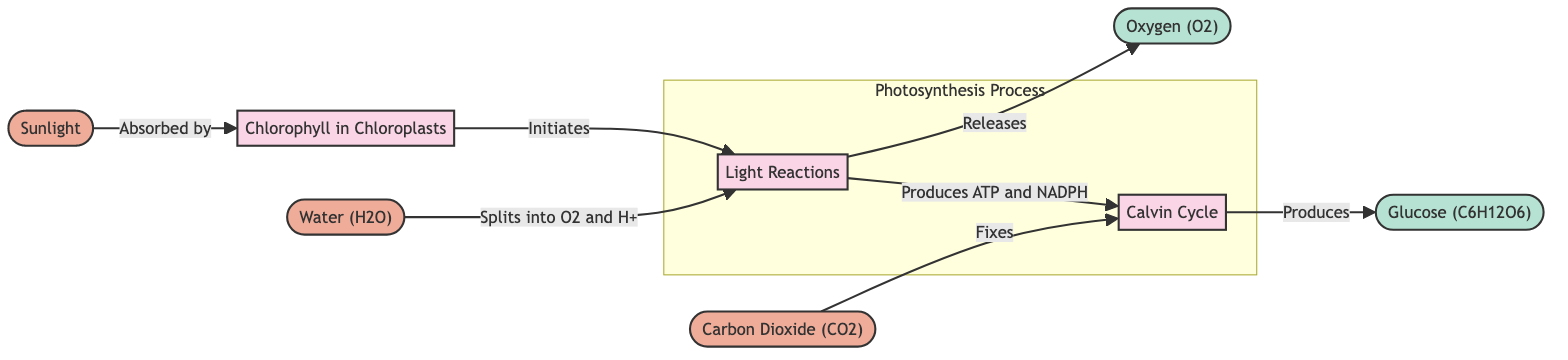What is the first input in the process? The diagram indicates that the first input in the process of photosynthesis is sunlight, which is also the first node listed on the left.
Answer: Sunlight How many outputs are generated in this diagram? By examining the diagram, we can see there are two outputs: oxygen and glucose. Therefore, adding these gives a total of two outputs.
Answer: 2 What is produced during the light reactions? According to the diagram, the light reactions produce ATP and NADPH, which are necessary for the subsequent Calvin cycle.
Answer: ATP and NADPH Which process follows the light reactions? The diagram shows a direct connection from the light reactions to the Calvin cycle, indicating that the Calvin cycle follows next in the overall process.
Answer: Calvin Cycle What happens to water during the light reactions? The diagram states that water splits into oxygen and hydrogen ions during the light reactions, highlighting its role.
Answer: Splits into O2 and H+ What is the role of chlorophyll in the process? The diagram explains that chlorophyll absorbs sunlight, initiating the light reactions crucial for photosynthesis.
Answer: Absorbs sunlight How does carbon dioxide contribute to glucose production? The diagram states that carbon dioxide is fixed in the Calvin cycle, leading to the production of glucose, showing its role in forming glucose.
Answer: Fixes What is released at the end of the light reactions? The diagram explicitly shows that oxygen is released as a byproduct of the light reactions, highlighting its significance in the process.
Answer: Oxygen 